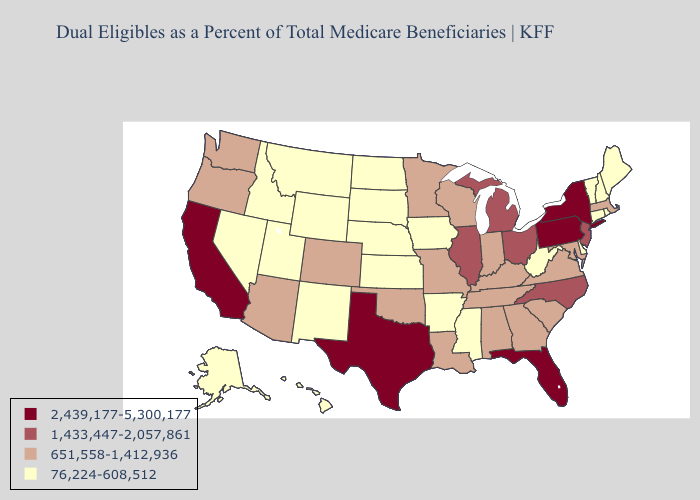What is the highest value in the USA?
Concise answer only. 2,439,177-5,300,177. Does West Virginia have the highest value in the South?
Quick response, please. No. Does Utah have a lower value than Rhode Island?
Answer briefly. No. Which states have the highest value in the USA?
Give a very brief answer. California, Florida, New York, Pennsylvania, Texas. Does Delaware have the lowest value in the South?
Quick response, please. Yes. What is the lowest value in the USA?
Write a very short answer. 76,224-608,512. Name the states that have a value in the range 2,439,177-5,300,177?
Concise answer only. California, Florida, New York, Pennsylvania, Texas. What is the value of Alabama?
Give a very brief answer. 651,558-1,412,936. What is the value of Oklahoma?
Answer briefly. 651,558-1,412,936. Does New Hampshire have the lowest value in the USA?
Answer briefly. Yes. Name the states that have a value in the range 1,433,447-2,057,861?
Concise answer only. Illinois, Michigan, New Jersey, North Carolina, Ohio. Name the states that have a value in the range 76,224-608,512?
Concise answer only. Alaska, Arkansas, Connecticut, Delaware, Hawaii, Idaho, Iowa, Kansas, Maine, Mississippi, Montana, Nebraska, Nevada, New Hampshire, New Mexico, North Dakota, Rhode Island, South Dakota, Utah, Vermont, West Virginia, Wyoming. Does California have the highest value in the USA?
Be succinct. Yes. What is the value of Missouri?
Be succinct. 651,558-1,412,936. Among the states that border Nebraska , does Colorado have the lowest value?
Concise answer only. No. 